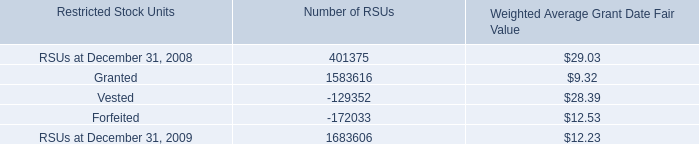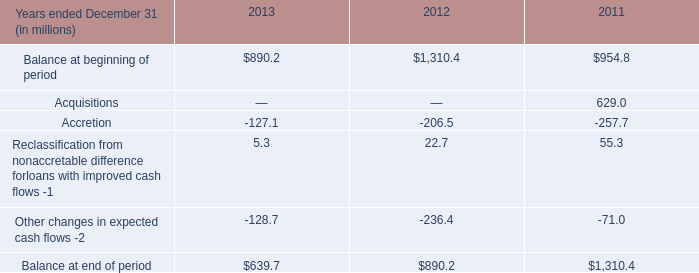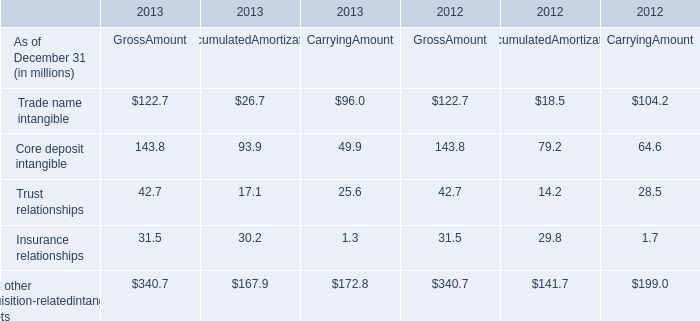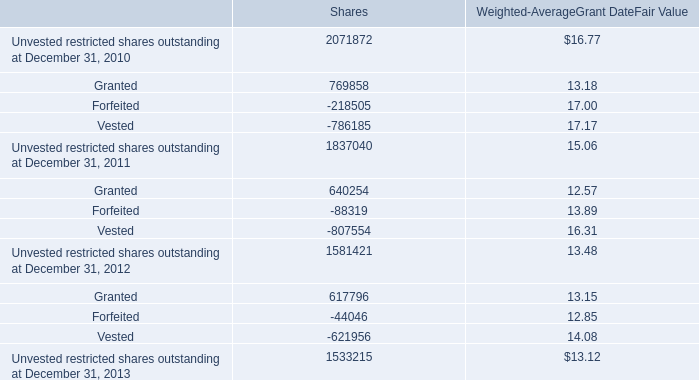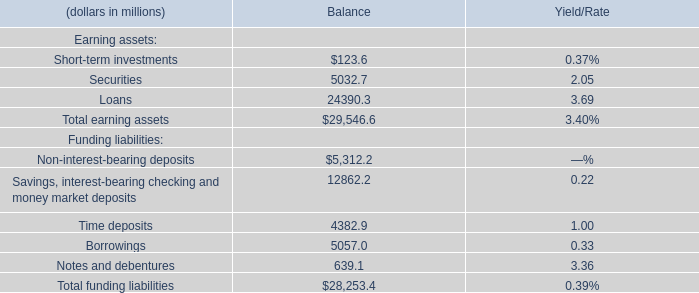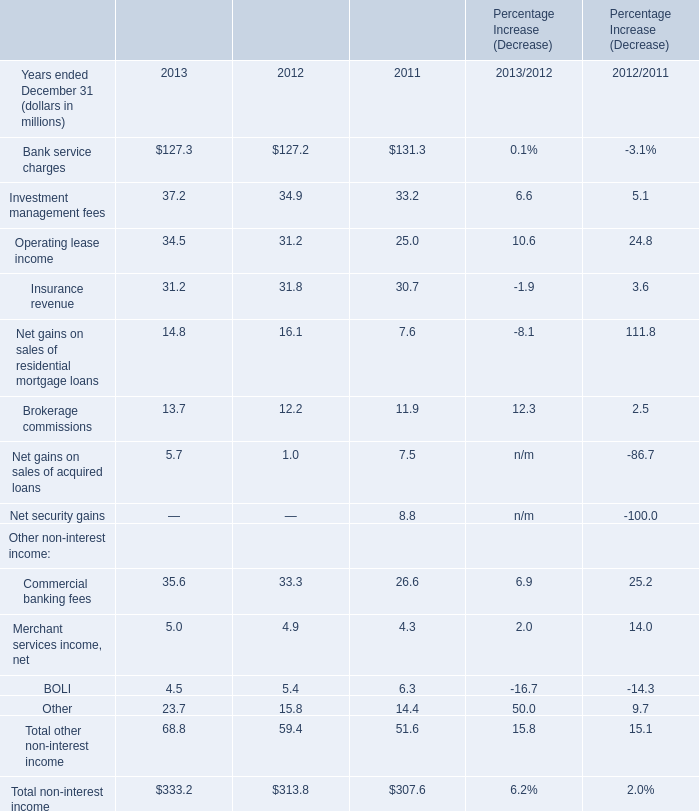what's the total amount of Granted of Number of RSUs, and Balance at end of period of 2011 ? 
Computations: (1583616.0 + 1310.4)
Answer: 1584926.4. 